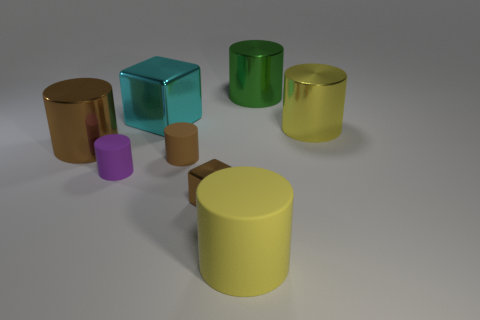What size is the matte object that is the same color as the small block?
Provide a succinct answer. Small. There is a brown shiny thing left of the large cyan shiny object; is it the same size as the cube in front of the big brown metal thing?
Your answer should be compact. No. What size is the metal object that is to the left of the small purple rubber cylinder?
Your answer should be compact. Large. Are there any other objects that have the same color as the large rubber object?
Keep it short and to the point. Yes. Are there any small brown shiny things right of the small cylinder that is right of the large cyan metal object?
Your response must be concise. Yes. Is the size of the brown cube the same as the yellow cylinder that is right of the large yellow rubber object?
Provide a succinct answer. No. There is a brown metal object that is on the right side of the metal thing on the left side of the big cyan block; is there a large cylinder that is right of it?
Provide a succinct answer. Yes. There is a big thing that is on the right side of the green thing; what is it made of?
Provide a succinct answer. Metal. Do the yellow matte object and the brown matte thing have the same size?
Ensure brevity in your answer.  No. The matte object that is both behind the large rubber cylinder and right of the large shiny block is what color?
Your answer should be very brief. Brown. 